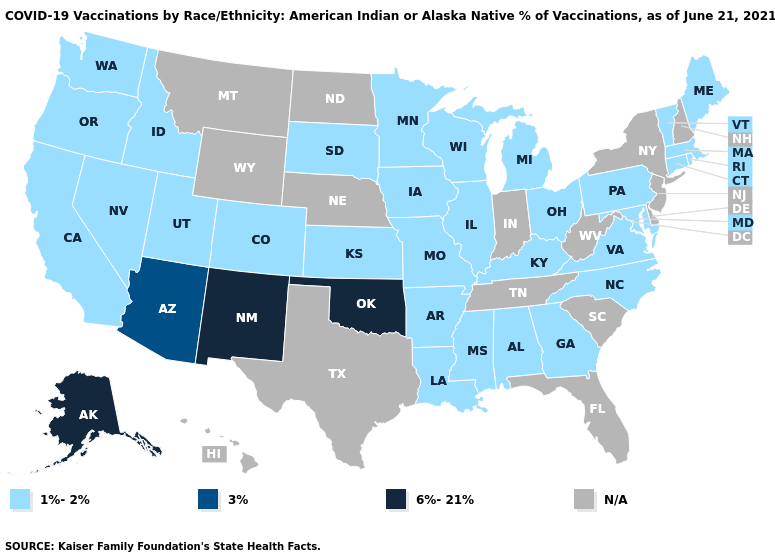Name the states that have a value in the range 1%-2%?
Write a very short answer. Alabama, Arkansas, California, Colorado, Connecticut, Georgia, Idaho, Illinois, Iowa, Kansas, Kentucky, Louisiana, Maine, Maryland, Massachusetts, Michigan, Minnesota, Mississippi, Missouri, Nevada, North Carolina, Ohio, Oregon, Pennsylvania, Rhode Island, South Dakota, Utah, Vermont, Virginia, Washington, Wisconsin. Does Idaho have the lowest value in the West?
Short answer required. Yes. What is the value of Ohio?
Concise answer only. 1%-2%. What is the lowest value in the MidWest?
Answer briefly. 1%-2%. What is the value of Colorado?
Keep it brief. 1%-2%. Name the states that have a value in the range 1%-2%?
Answer briefly. Alabama, Arkansas, California, Colorado, Connecticut, Georgia, Idaho, Illinois, Iowa, Kansas, Kentucky, Louisiana, Maine, Maryland, Massachusetts, Michigan, Minnesota, Mississippi, Missouri, Nevada, North Carolina, Ohio, Oregon, Pennsylvania, Rhode Island, South Dakota, Utah, Vermont, Virginia, Washington, Wisconsin. Among the states that border Texas , does New Mexico have the highest value?
Short answer required. Yes. What is the value of Louisiana?
Be succinct. 1%-2%. What is the value of Oregon?
Be succinct. 1%-2%. Name the states that have a value in the range 3%?
Write a very short answer. Arizona. What is the lowest value in the Northeast?
Write a very short answer. 1%-2%. Does the map have missing data?
Write a very short answer. Yes. 